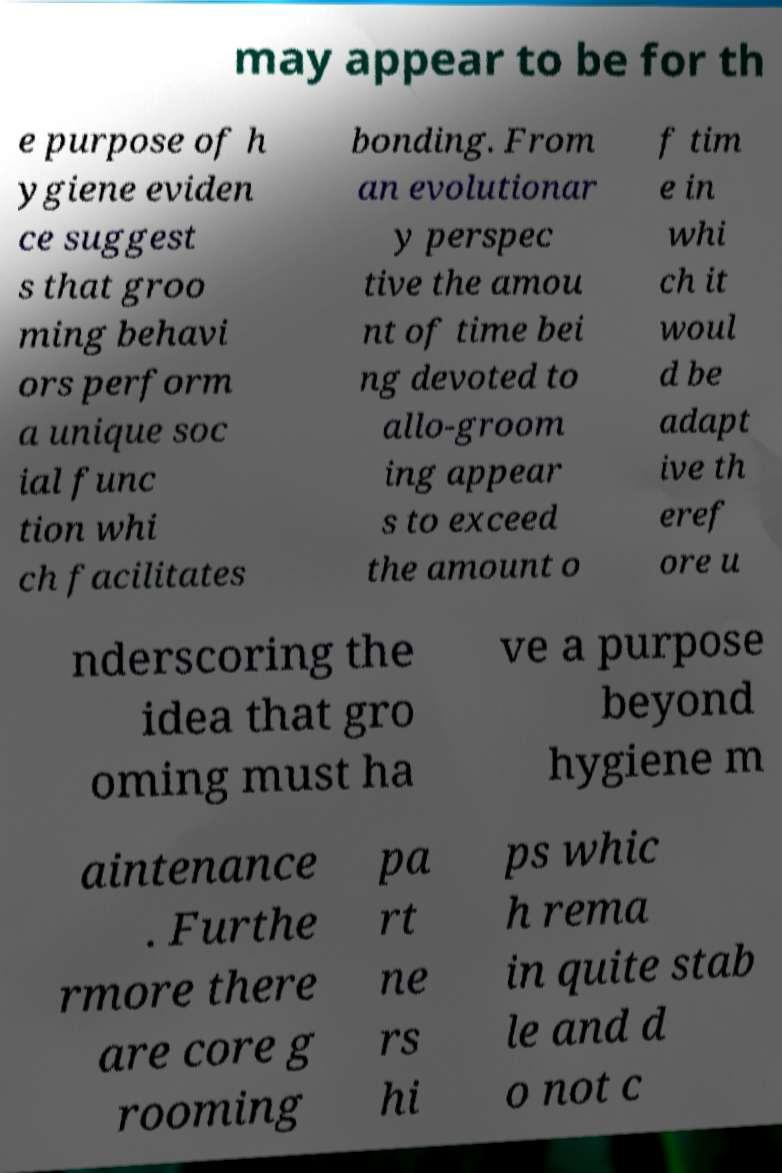What messages or text are displayed in this image? I need them in a readable, typed format. may appear to be for th e purpose of h ygiene eviden ce suggest s that groo ming behavi ors perform a unique soc ial func tion whi ch facilitates bonding. From an evolutionar y perspec tive the amou nt of time bei ng devoted to allo-groom ing appear s to exceed the amount o f tim e in whi ch it woul d be adapt ive th eref ore u nderscoring the idea that gro oming must ha ve a purpose beyond hygiene m aintenance . Furthe rmore there are core g rooming pa rt ne rs hi ps whic h rema in quite stab le and d o not c 